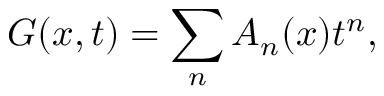Convert formula to latex. <formula><loc_0><loc_0><loc_500><loc_500>G ( x , t ) = \sum _ { n } A _ { n } ( x ) t ^ { n } ,</formula> 